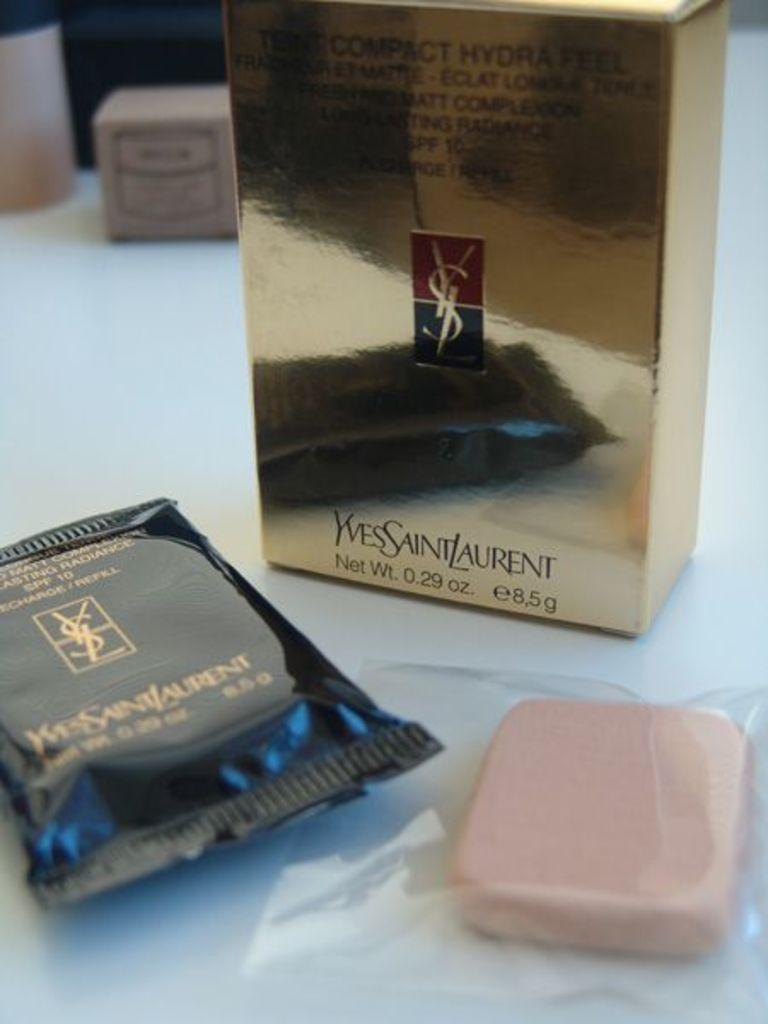<image>
Offer a succinct explanation of the picture presented. A few packs of soap called Yves Saint Laurent 